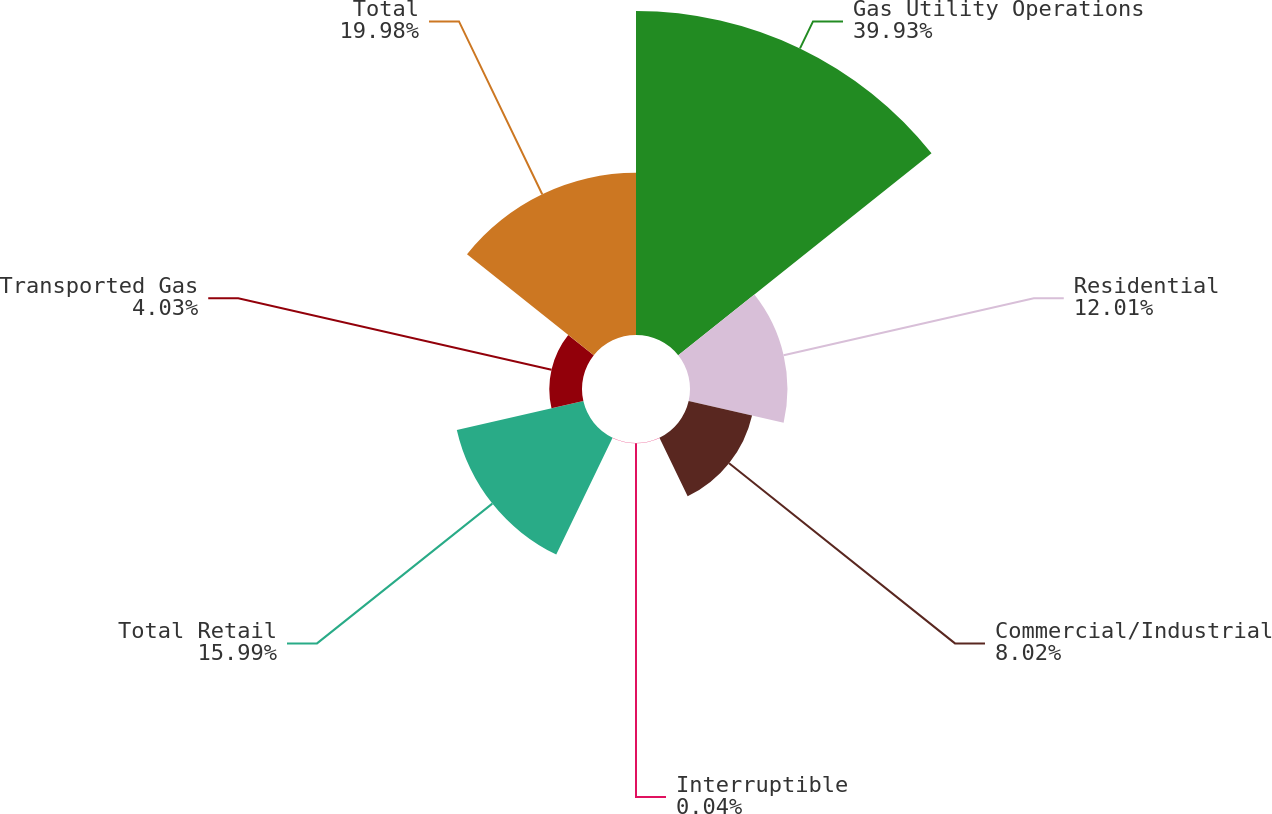Convert chart. <chart><loc_0><loc_0><loc_500><loc_500><pie_chart><fcel>Gas Utility Operations<fcel>Residential<fcel>Commercial/Industrial<fcel>Interruptible<fcel>Total Retail<fcel>Transported Gas<fcel>Total<nl><fcel>39.94%<fcel>12.01%<fcel>8.02%<fcel>0.04%<fcel>16.0%<fcel>4.03%<fcel>19.99%<nl></chart> 